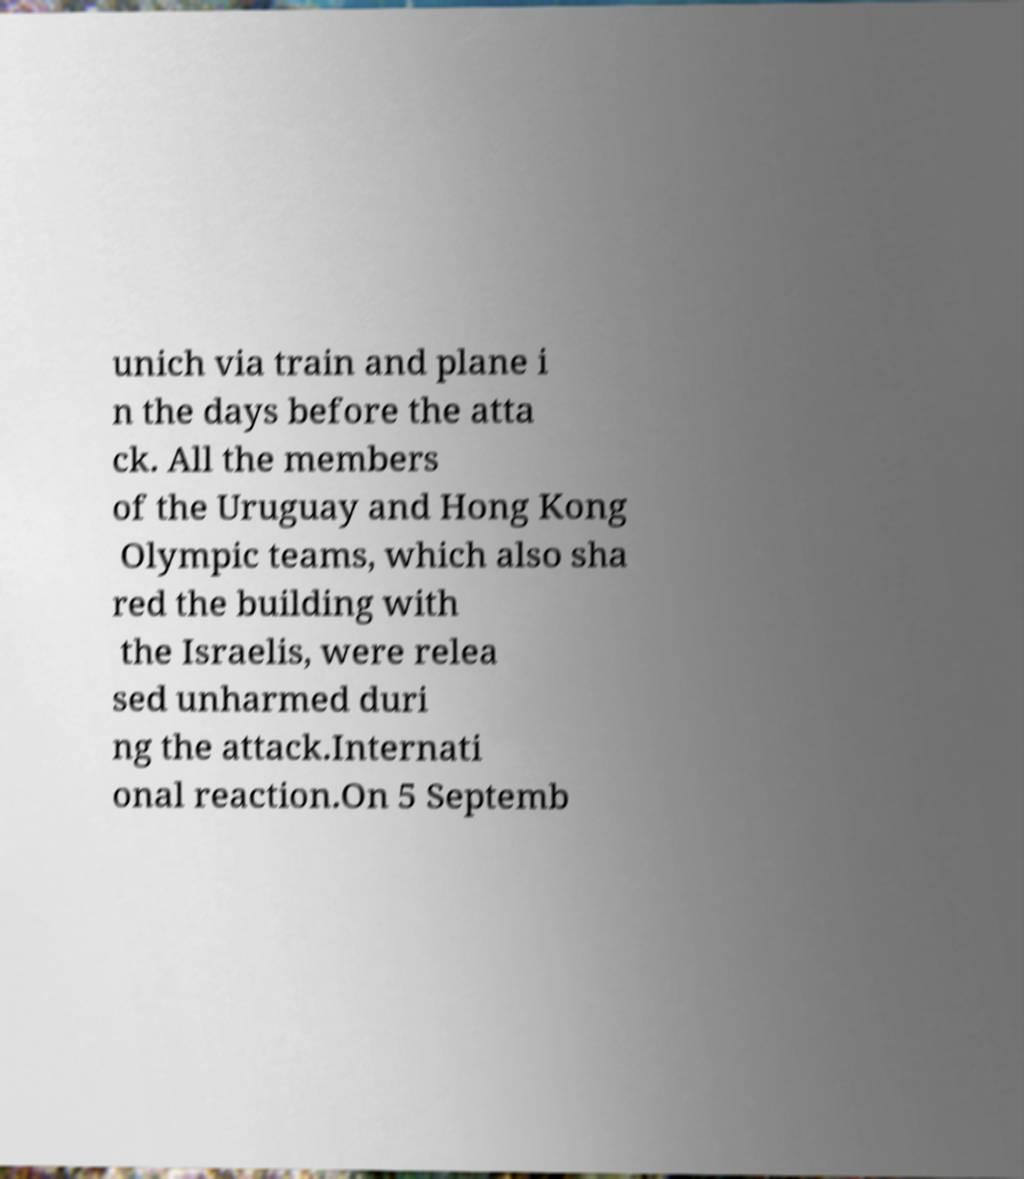I need the written content from this picture converted into text. Can you do that? unich via train and plane i n the days before the atta ck. All the members of the Uruguay and Hong Kong Olympic teams, which also sha red the building with the Israelis, were relea sed unharmed duri ng the attack.Internati onal reaction.On 5 Septemb 